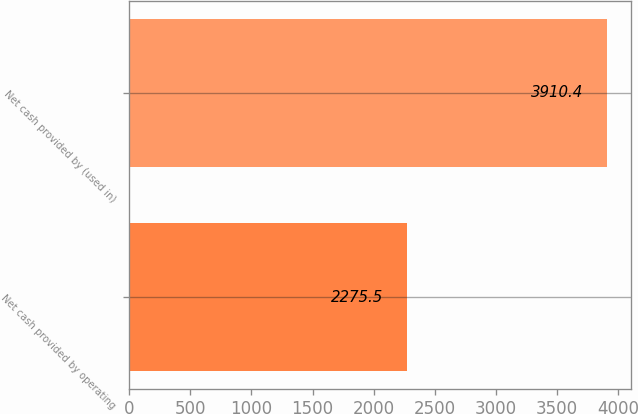Convert chart to OTSL. <chart><loc_0><loc_0><loc_500><loc_500><bar_chart><fcel>Net cash provided by operating<fcel>Net cash provided by (used in)<nl><fcel>2275.5<fcel>3910.4<nl></chart> 